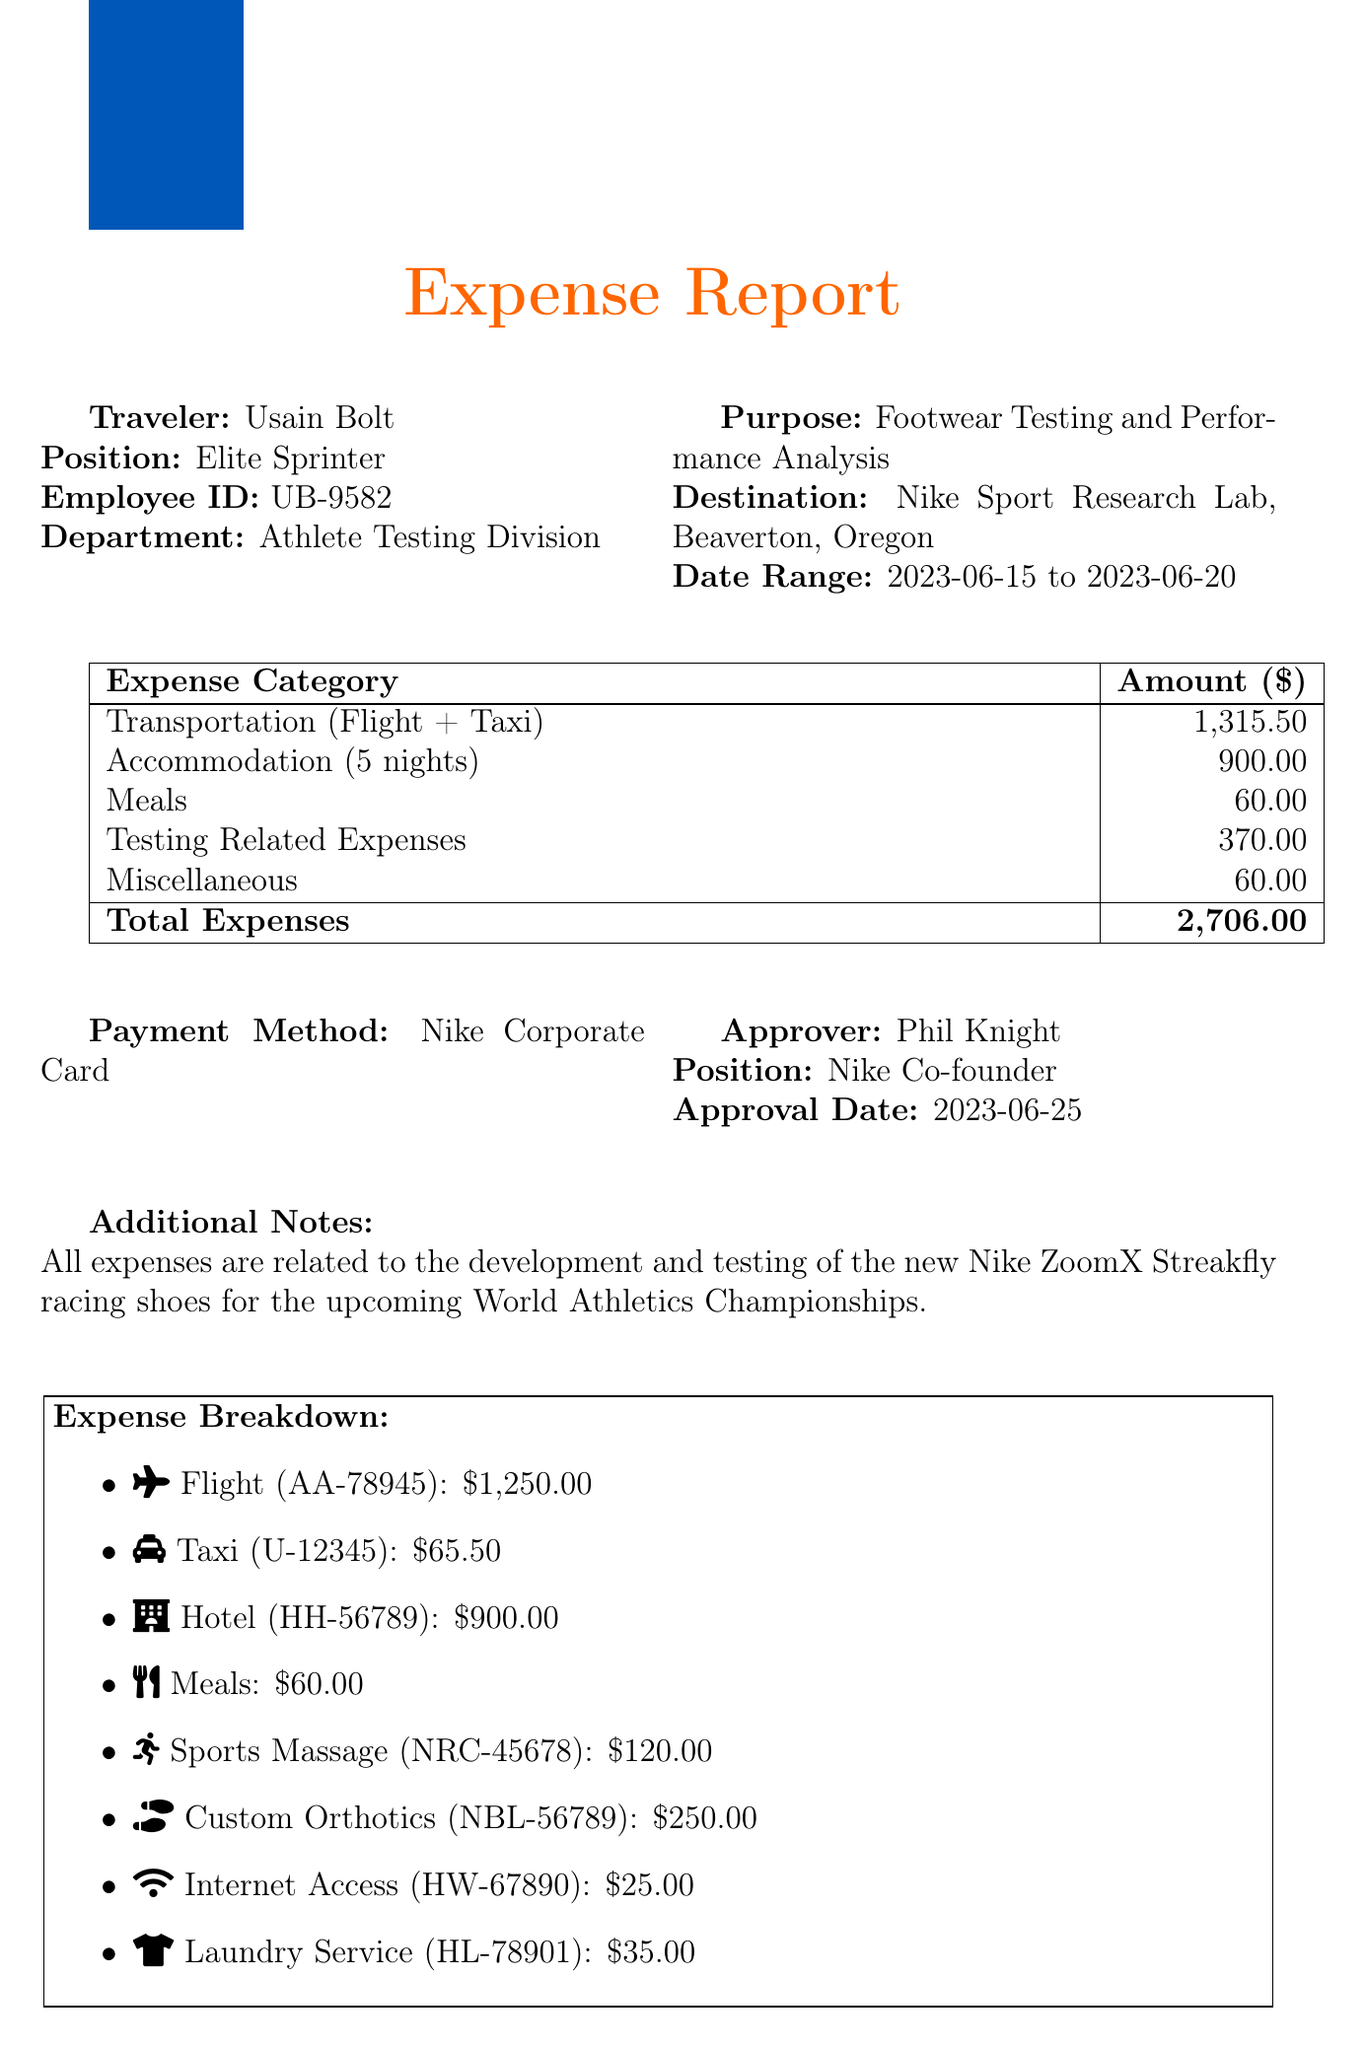What is the traveler's name? The traveler's name is listed in the document under traveler info.
Answer: Usain Bolt What is the purpose of the trip? The purpose of the trip is specifically stated in the trip details section.
Answer: Footwear Testing and Performance Analysis How many nights did the traveler stay at the hotel? The number of nights can be found in the accommodation expenses section of the document.
Answer: 5 What was the total cost of transportation? The total cost of transportation combines all transportation expenses found in the document.
Answer: 1,315.50 Who approved the expense report? The approver's name is detailed in the approval info section of the document.
Answer: Phil Knight What was the date range of the trip? The date range is clearly mentioned in the trip details section of the document.
Answer: 2023-06-15 to 2023-06-20 How much did the traveler spend on sports massage? The cost for sports massage is provided in the testing-related expenses section.
Answer: 120.00 What type of payment method was used? The payment method is explicitly stated in the document.
Answer: Nike Corporate Card What is the total expense amount? The total amount is stated clearly at the end of the expense breakdown table.
Answer: 2,706.00 